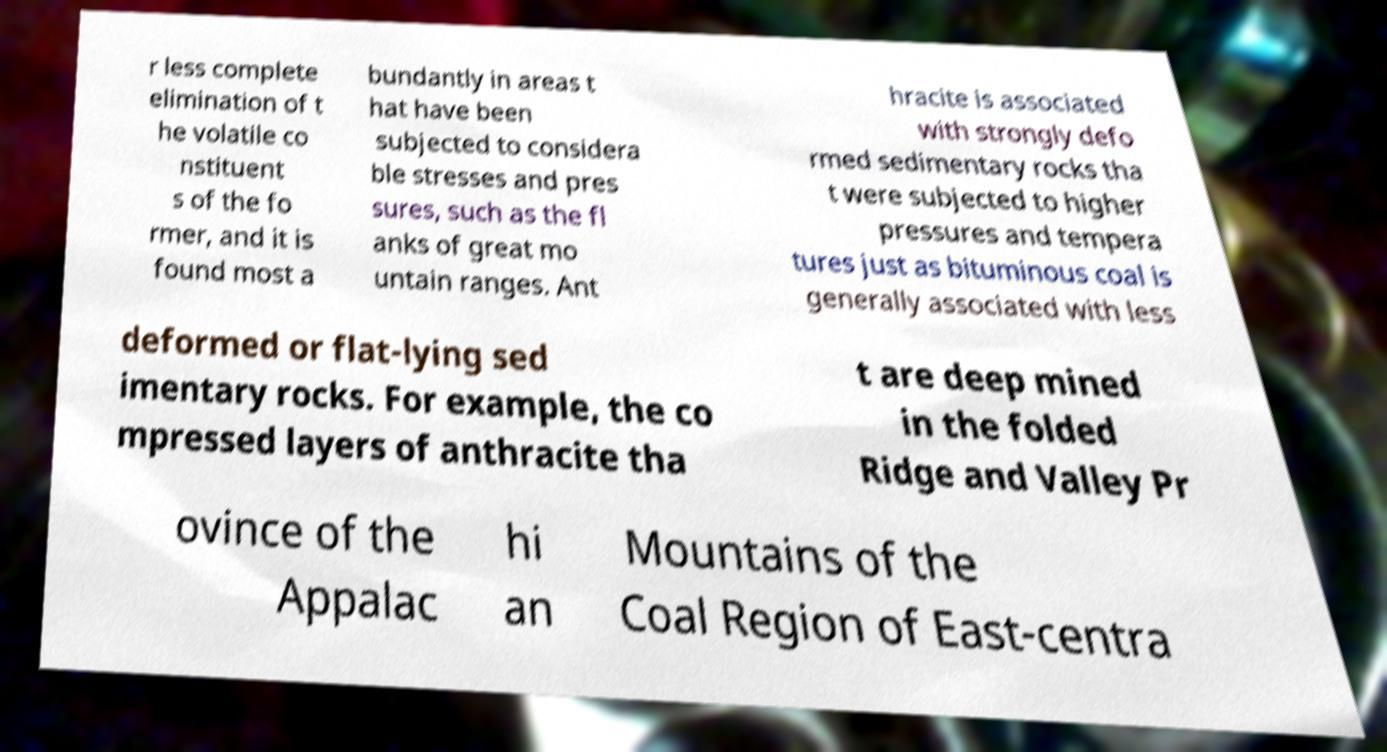What messages or text are displayed in this image? I need them in a readable, typed format. r less complete elimination of t he volatile co nstituent s of the fo rmer, and it is found most a bundantly in areas t hat have been subjected to considera ble stresses and pres sures, such as the fl anks of great mo untain ranges. Ant hracite is associated with strongly defo rmed sedimentary rocks tha t were subjected to higher pressures and tempera tures just as bituminous coal is generally associated with less deformed or flat-lying sed imentary rocks. For example, the co mpressed layers of anthracite tha t are deep mined in the folded Ridge and Valley Pr ovince of the Appalac hi an Mountains of the Coal Region of East-centra 